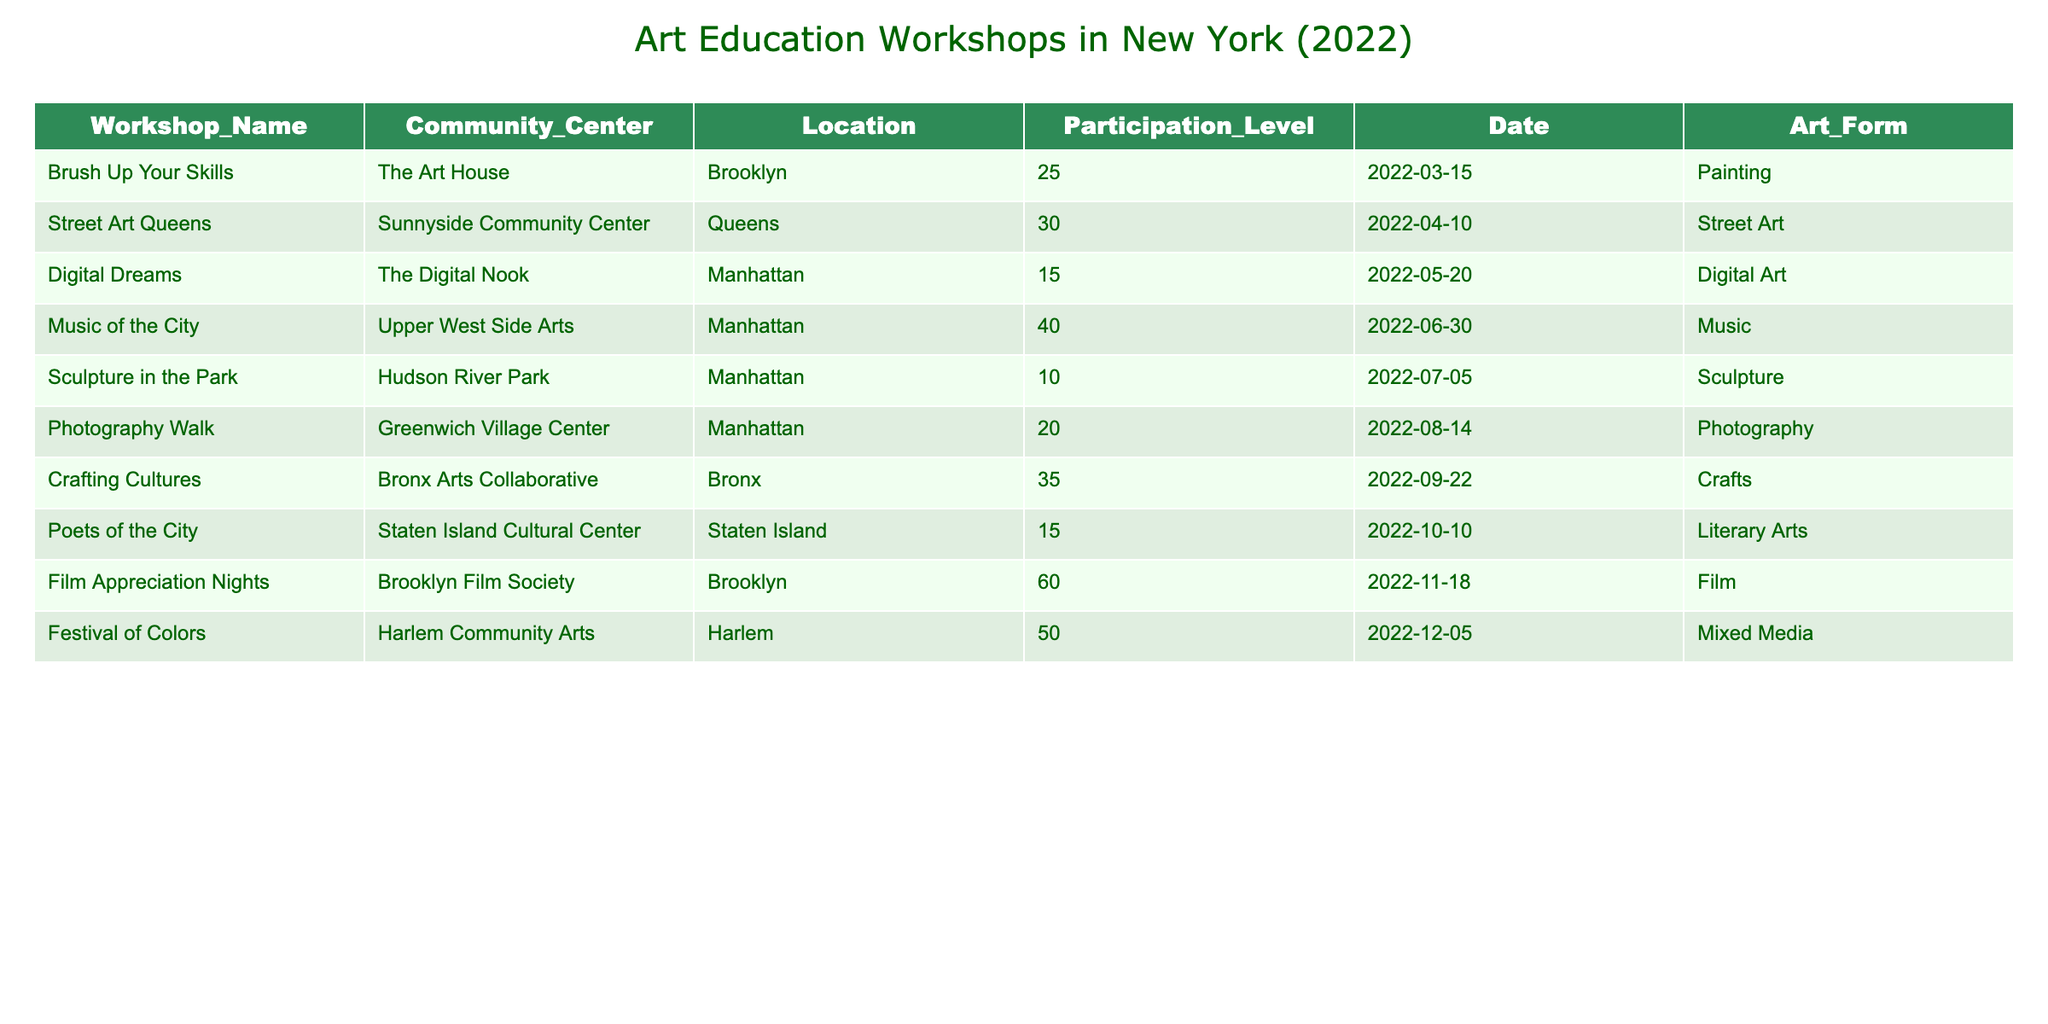What is the participation level of the "Film Appreciation Nights" workshop? The participation level for "Film Appreciation Nights" is 60, as listed in the table under the Participation_Level column.
Answer: 60 Which art form had the highest participation level? By comparing all the participation levels in the table, "Film" has the highest participation level of 60.
Answer: Film How many participants attended the "Street Art Queens" workshop? The number of participants for "Street Art Queens" is given as 30 in the table.
Answer: 30 What is the total participation level of all the workshops offered? Adding all the participation levels from each workshop (25 + 30 + 15 + 40 + 10 + 20 + 35 + 15 + 60 + 50) results in a total participation level of 320.
Answer: 320 Is there any workshop that had fewer than 15 participants? Checking the Participation_Level column, "Sculpture in the Park" had 10 participants, which is fewer than 15.
Answer: Yes What is the average participation level across all workshops? The average participation is calculated by summing all participation levels (320) and dividing by the number of workshops (10). Thus, 320 / 10 = 32.
Answer: 32 Which community center hosted the workshop with the minimum participation? The "Sculpture in the Park" hosted by Hudson River Park had the minimum participation of 10, making it the workshop with the least attendance.
Answer: Hudson River Park How many workshops had a participation level above 30? The workshops with participation above 30 are "Street Art Queens" (30), "Music of the City" (40), "Film Appreciation Nights" (60), and "Festival of Colors" (50). Thus, 4 workshops exceed a participation level of 30 participants.
Answer: 4 What is the difference in participation between the highest and lowest workshop? The highest attendance is 60 (Film) and the lowest is 10 (Sculpture). The difference is calculated by subtracting the lowest from the highest: 60 - 10 = 50.
Answer: 50 Which two workshops had the closest participation levels? The workshops with close participation levels are "Photography Walk" (20) and "Poets of the City" (15). The differences are small, making them the pair with closest levels since both are under 30.
Answer: Photography Walk and Poets of the City 